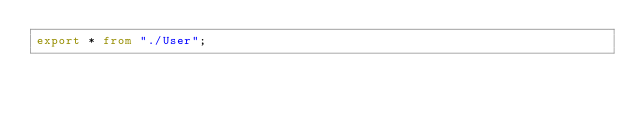<code> <loc_0><loc_0><loc_500><loc_500><_TypeScript_>export * from "./User";</code> 